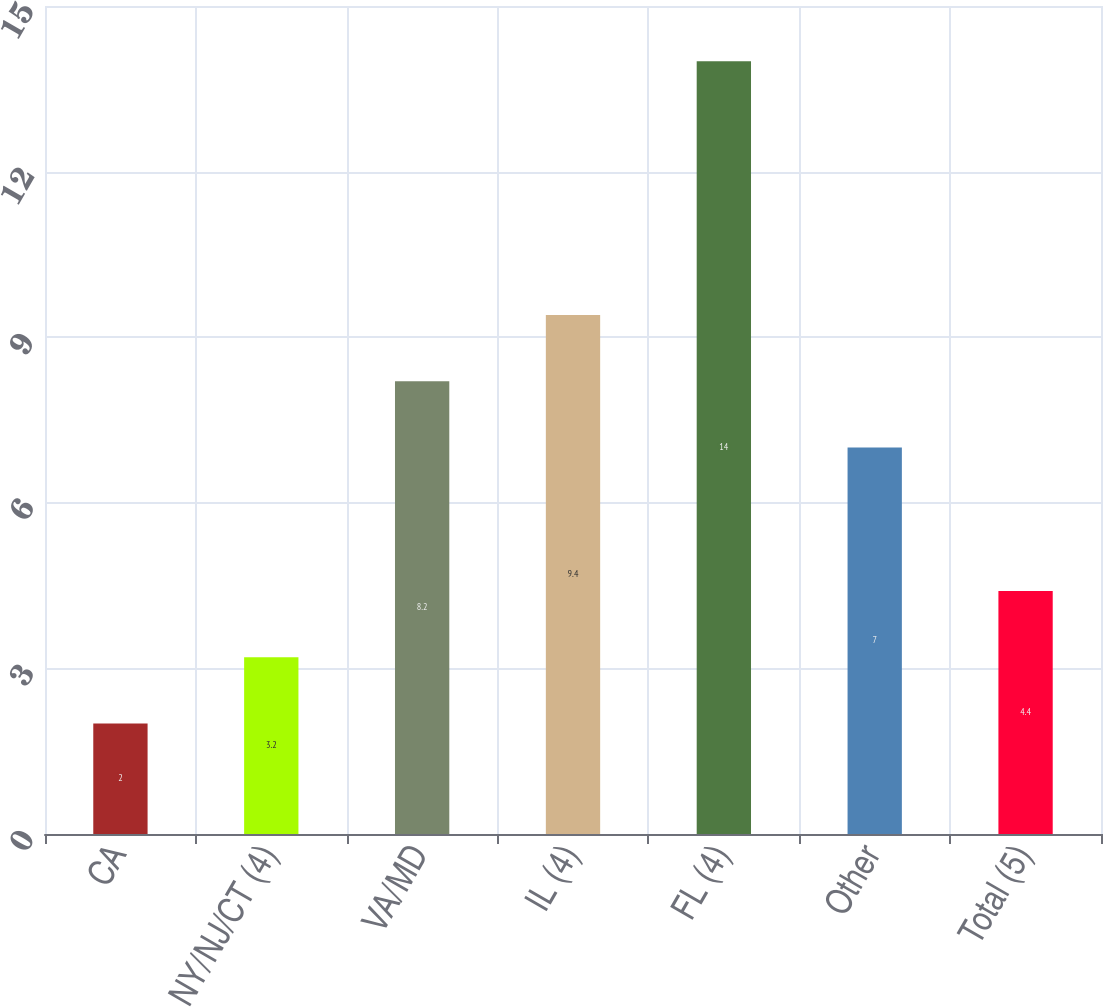Convert chart to OTSL. <chart><loc_0><loc_0><loc_500><loc_500><bar_chart><fcel>CA<fcel>NY/NJ/CT (4)<fcel>VA/MD<fcel>IL (4)<fcel>FL (4)<fcel>Other<fcel>Total (5)<nl><fcel>2<fcel>3.2<fcel>8.2<fcel>9.4<fcel>14<fcel>7<fcel>4.4<nl></chart> 